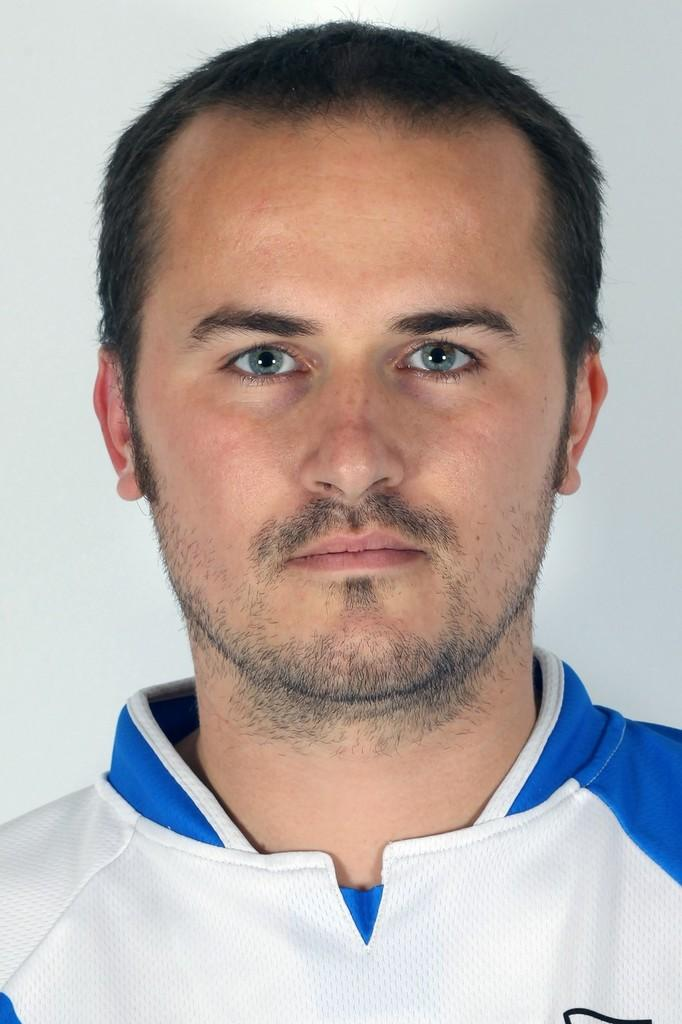What is present in the image? There is a person in the image. Can you describe the person's clothing? The person is wearing a white and blue color shirt. Is the person giving a baby a bath in the image? There is no baby or bath present in the image; it only features a person wearing a white and blue color shirt. 